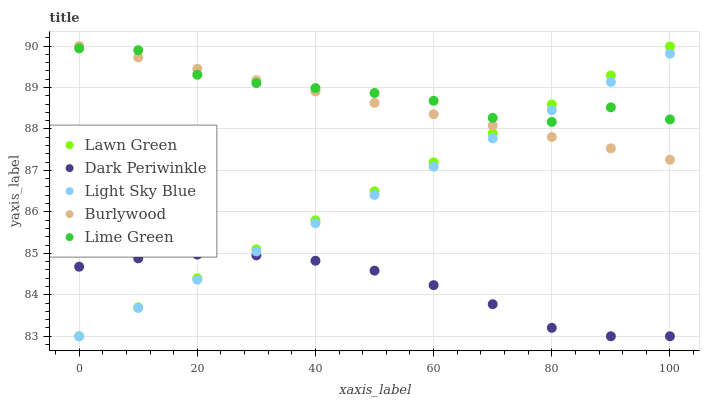Does Dark Periwinkle have the minimum area under the curve?
Answer yes or no. Yes. Does Lime Green have the maximum area under the curve?
Answer yes or no. Yes. Does Lawn Green have the minimum area under the curve?
Answer yes or no. No. Does Lawn Green have the maximum area under the curve?
Answer yes or no. No. Is Burlywood the smoothest?
Answer yes or no. Yes. Is Lime Green the roughest?
Answer yes or no. Yes. Is Lawn Green the smoothest?
Answer yes or no. No. Is Lawn Green the roughest?
Answer yes or no. No. Does Lawn Green have the lowest value?
Answer yes or no. Yes. Does Lime Green have the lowest value?
Answer yes or no. No. Does Burlywood have the highest value?
Answer yes or no. Yes. Does Lawn Green have the highest value?
Answer yes or no. No. Is Dark Periwinkle less than Burlywood?
Answer yes or no. Yes. Is Burlywood greater than Dark Periwinkle?
Answer yes or no. Yes. Does Light Sky Blue intersect Burlywood?
Answer yes or no. Yes. Is Light Sky Blue less than Burlywood?
Answer yes or no. No. Is Light Sky Blue greater than Burlywood?
Answer yes or no. No. Does Dark Periwinkle intersect Burlywood?
Answer yes or no. No. 